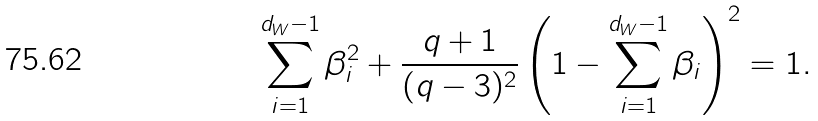Convert formula to latex. <formula><loc_0><loc_0><loc_500><loc_500>\sum _ { i = 1 } ^ { d _ { W } - 1 } \beta _ { i } ^ { 2 } + \frac { q + 1 } { ( q - 3 ) ^ { 2 } } \left ( 1 - \sum _ { i = 1 } ^ { d _ { W } - 1 } \beta _ { i } \right ) ^ { 2 } = 1 .</formula> 